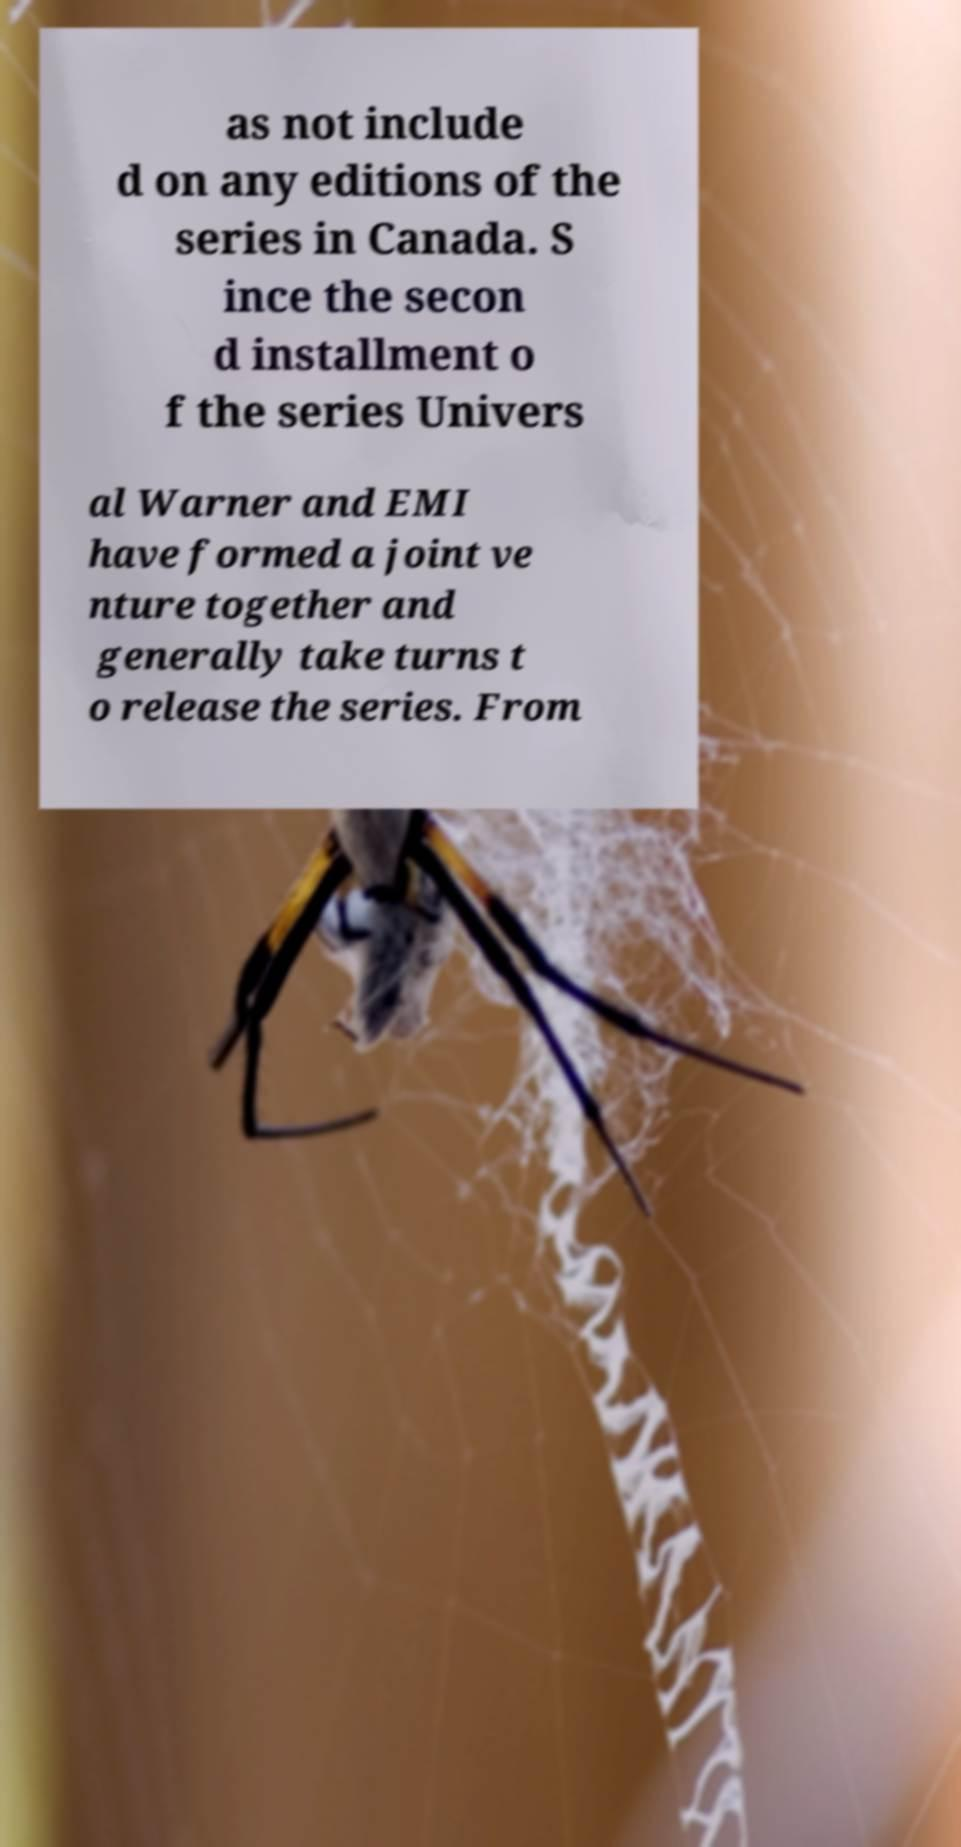I need the written content from this picture converted into text. Can you do that? as not include d on any editions of the series in Canada. S ince the secon d installment o f the series Univers al Warner and EMI have formed a joint ve nture together and generally take turns t o release the series. From 